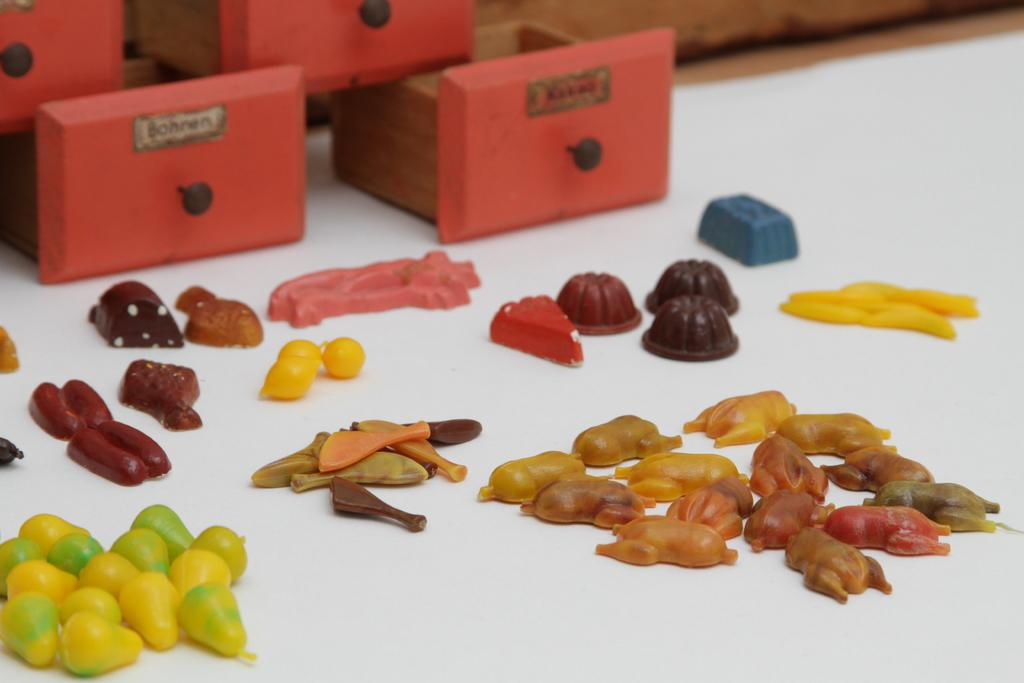What types of items are visible in the image? There are candies of different types in the image. What else can be seen in the image besides the candies? There are storage boxes in the image. Where are the storage boxes located? The storage boxes are placed on the floor. What news is being reported by the carriage in the image? There is no carriage present in the image, and therefore no news can be reported. 